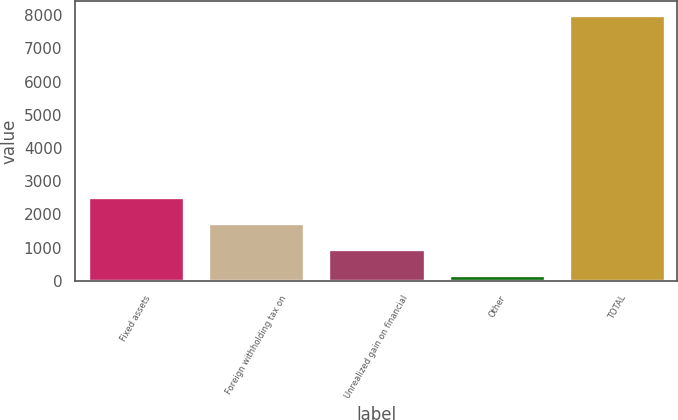Convert chart to OTSL. <chart><loc_0><loc_0><loc_500><loc_500><bar_chart><fcel>Fixed assets<fcel>Foreign withholding tax on<fcel>Unrealized gain on financial<fcel>Other<fcel>TOTAL<nl><fcel>2518.1<fcel>1732.4<fcel>946.7<fcel>161<fcel>8018<nl></chart> 